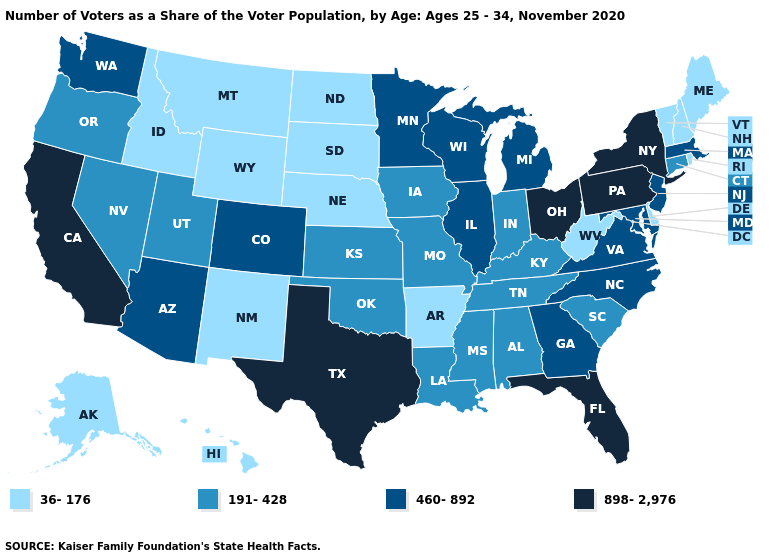Does Iowa have the same value as Tennessee?
Quick response, please. Yes. How many symbols are there in the legend?
Give a very brief answer. 4. Does the first symbol in the legend represent the smallest category?
Answer briefly. Yes. Does Maryland have the highest value in the USA?
Concise answer only. No. What is the lowest value in states that border Maine?
Write a very short answer. 36-176. Name the states that have a value in the range 36-176?
Write a very short answer. Alaska, Arkansas, Delaware, Hawaii, Idaho, Maine, Montana, Nebraska, New Hampshire, New Mexico, North Dakota, Rhode Island, South Dakota, Vermont, West Virginia, Wyoming. Among the states that border Pennsylvania , which have the lowest value?
Short answer required. Delaware, West Virginia. What is the lowest value in the USA?
Write a very short answer. 36-176. What is the lowest value in the USA?
Answer briefly. 36-176. Name the states that have a value in the range 191-428?
Concise answer only. Alabama, Connecticut, Indiana, Iowa, Kansas, Kentucky, Louisiana, Mississippi, Missouri, Nevada, Oklahoma, Oregon, South Carolina, Tennessee, Utah. Does Alabama have a higher value than Idaho?
Answer briefly. Yes. What is the value of Colorado?
Keep it brief. 460-892. What is the value of Tennessee?
Short answer required. 191-428. Name the states that have a value in the range 191-428?
Be succinct. Alabama, Connecticut, Indiana, Iowa, Kansas, Kentucky, Louisiana, Mississippi, Missouri, Nevada, Oklahoma, Oregon, South Carolina, Tennessee, Utah. Name the states that have a value in the range 191-428?
Quick response, please. Alabama, Connecticut, Indiana, Iowa, Kansas, Kentucky, Louisiana, Mississippi, Missouri, Nevada, Oklahoma, Oregon, South Carolina, Tennessee, Utah. 